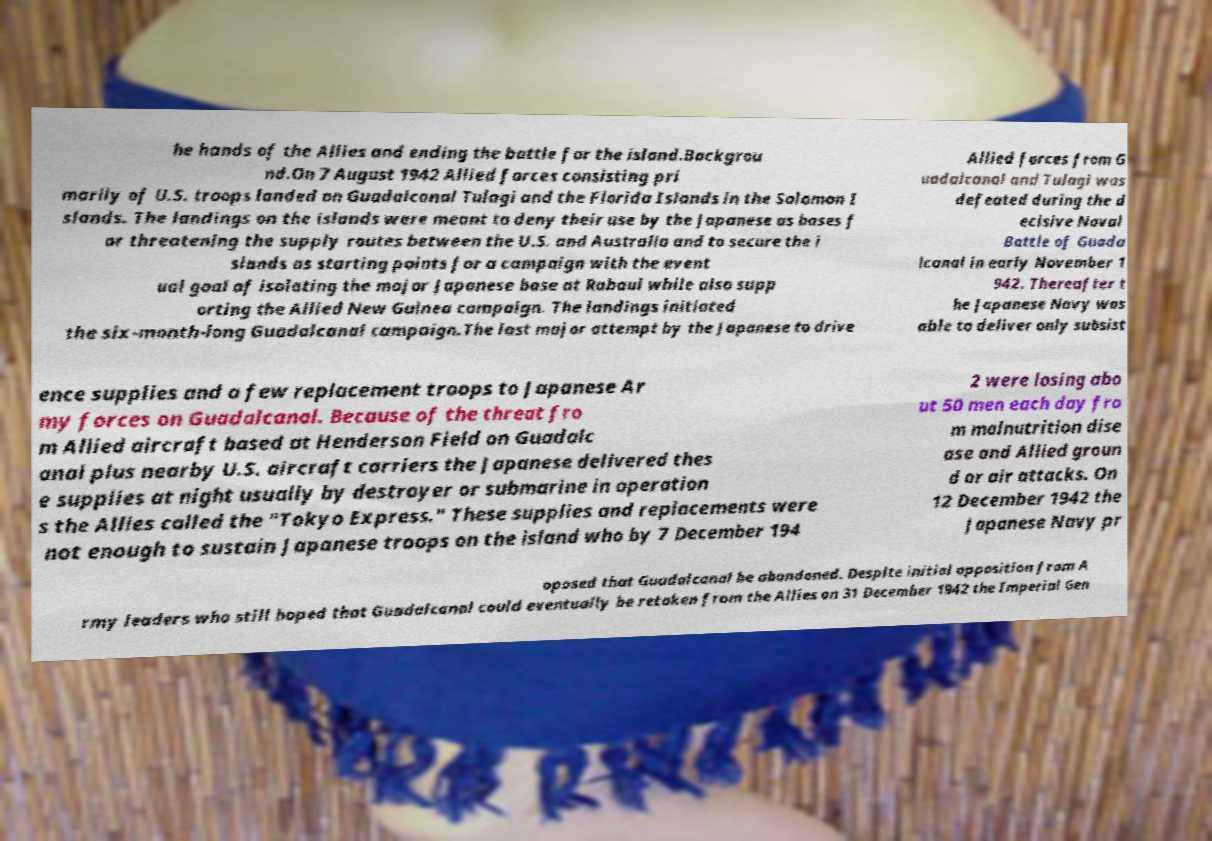Could you extract and type out the text from this image? he hands of the Allies and ending the battle for the island.Backgrou nd.On 7 August 1942 Allied forces consisting pri marily of U.S. troops landed on Guadalcanal Tulagi and the Florida Islands in the Solomon I slands. The landings on the islands were meant to deny their use by the Japanese as bases f or threatening the supply routes between the U.S. and Australia and to secure the i slands as starting points for a campaign with the event ual goal of isolating the major Japanese base at Rabaul while also supp orting the Allied New Guinea campaign. The landings initiated the six-month-long Guadalcanal campaign.The last major attempt by the Japanese to drive Allied forces from G uadalcanal and Tulagi was defeated during the d ecisive Naval Battle of Guada lcanal in early November 1 942. Thereafter t he Japanese Navy was able to deliver only subsist ence supplies and a few replacement troops to Japanese Ar my forces on Guadalcanal. Because of the threat fro m Allied aircraft based at Henderson Field on Guadalc anal plus nearby U.S. aircraft carriers the Japanese delivered thes e supplies at night usually by destroyer or submarine in operation s the Allies called the "Tokyo Express." These supplies and replacements were not enough to sustain Japanese troops on the island who by 7 December 194 2 were losing abo ut 50 men each day fro m malnutrition dise ase and Allied groun d or air attacks. On 12 December 1942 the Japanese Navy pr oposed that Guadalcanal be abandoned. Despite initial opposition from A rmy leaders who still hoped that Guadalcanal could eventually be retaken from the Allies on 31 December 1942 the Imperial Gen 